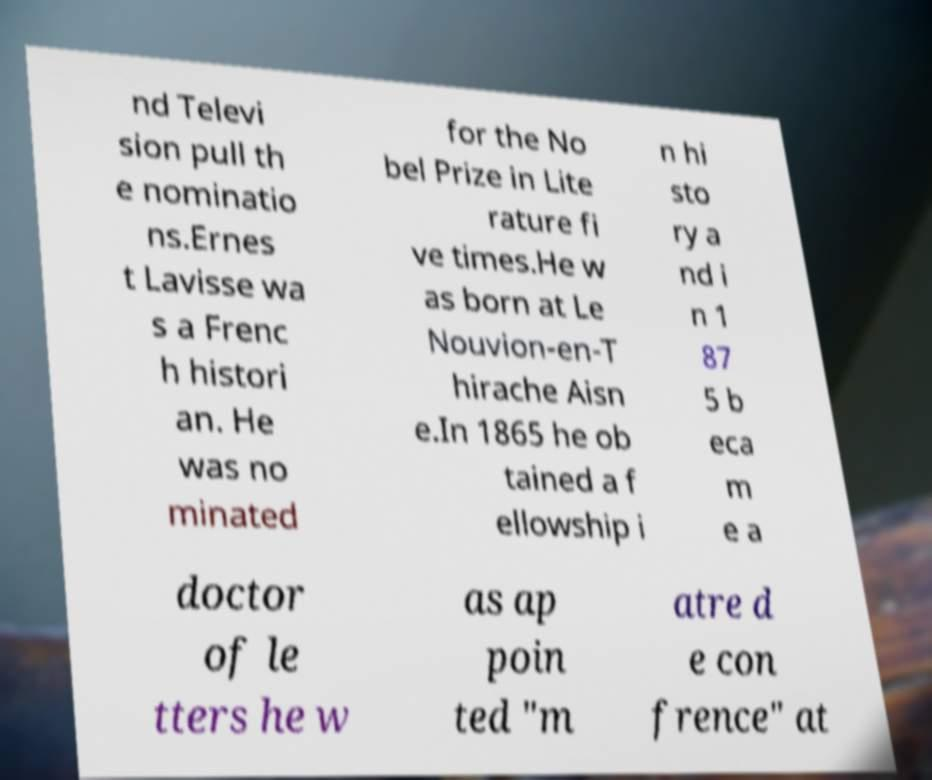Can you accurately transcribe the text from the provided image for me? nd Televi sion pull th e nominatio ns.Ernes t Lavisse wa s a Frenc h histori an. He was no minated for the No bel Prize in Lite rature fi ve times.He w as born at Le Nouvion-en-T hirache Aisn e.In 1865 he ob tained a f ellowship i n hi sto ry a nd i n 1 87 5 b eca m e a doctor of le tters he w as ap poin ted "m atre d e con frence" at 